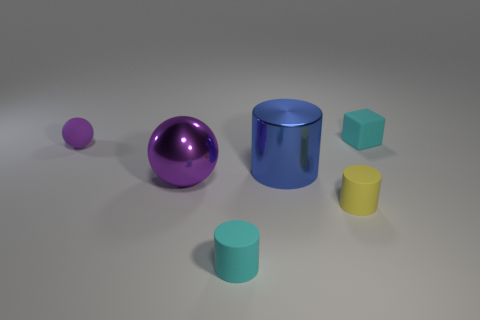The other metallic object that is the same size as the blue shiny object is what shape?
Give a very brief answer. Sphere. Are there any other things that have the same color as the large metallic cylinder?
Your response must be concise. No. There is a cyan cylinder that is made of the same material as the small yellow object; what size is it?
Provide a succinct answer. Small. Is the shape of the large blue metallic thing the same as the tiny cyan thing that is to the left of the metallic cylinder?
Provide a succinct answer. Yes. What size is the blue thing?
Offer a very short reply. Large. Is the number of small cyan cubes that are on the left side of the large ball less than the number of balls?
Keep it short and to the point. Yes. What number of matte cylinders have the same size as the cube?
Provide a short and direct response. 2. There is a metal object that is the same color as the rubber sphere; what shape is it?
Offer a terse response. Sphere. Does the rubber thing that is behind the tiny rubber sphere have the same color as the cylinder that is on the left side of the blue metal cylinder?
Ensure brevity in your answer.  Yes. How many tiny cyan matte objects are on the left side of the large cylinder?
Give a very brief answer. 1. 